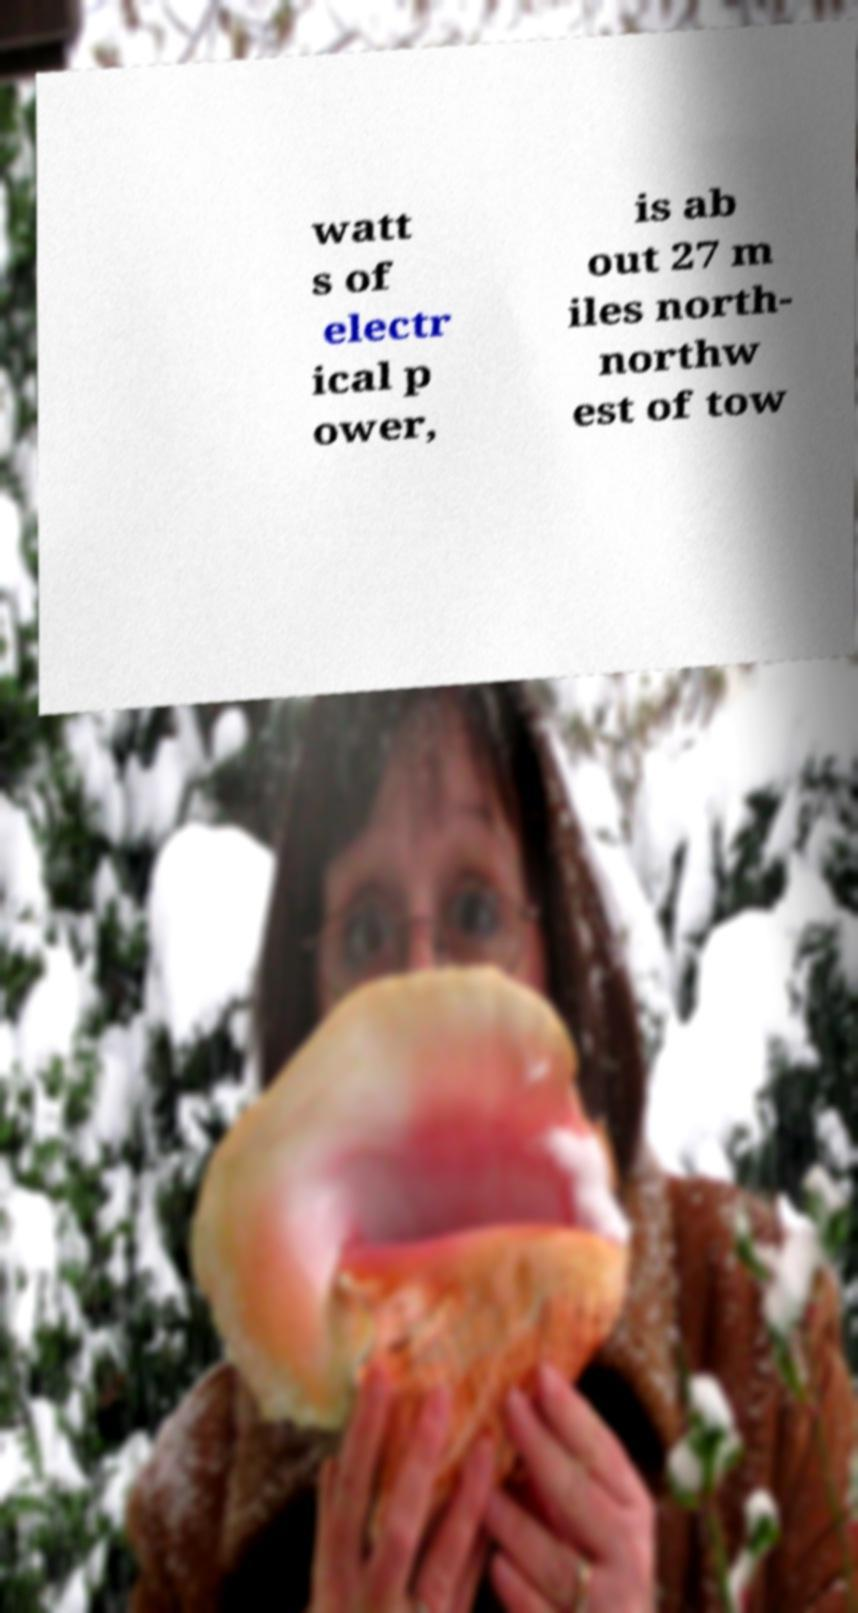Please identify and transcribe the text found in this image. watt s of electr ical p ower, is ab out 27 m iles north- northw est of tow 